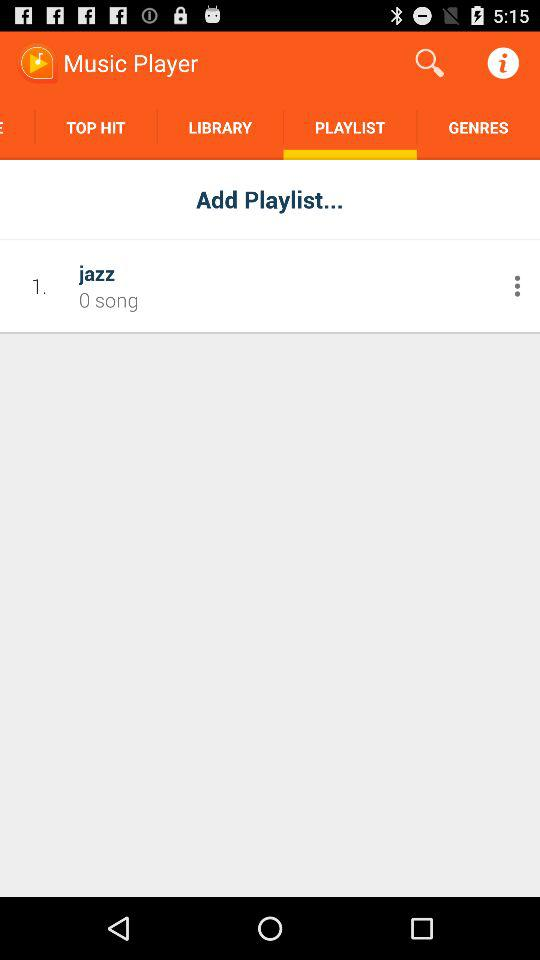Which tab is selected? The selected tab is "PLAYLIST". 